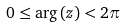Convert formula to latex. <formula><loc_0><loc_0><loc_500><loc_500>0 \leq \arg \left ( z \right ) < 2 \pi</formula> 